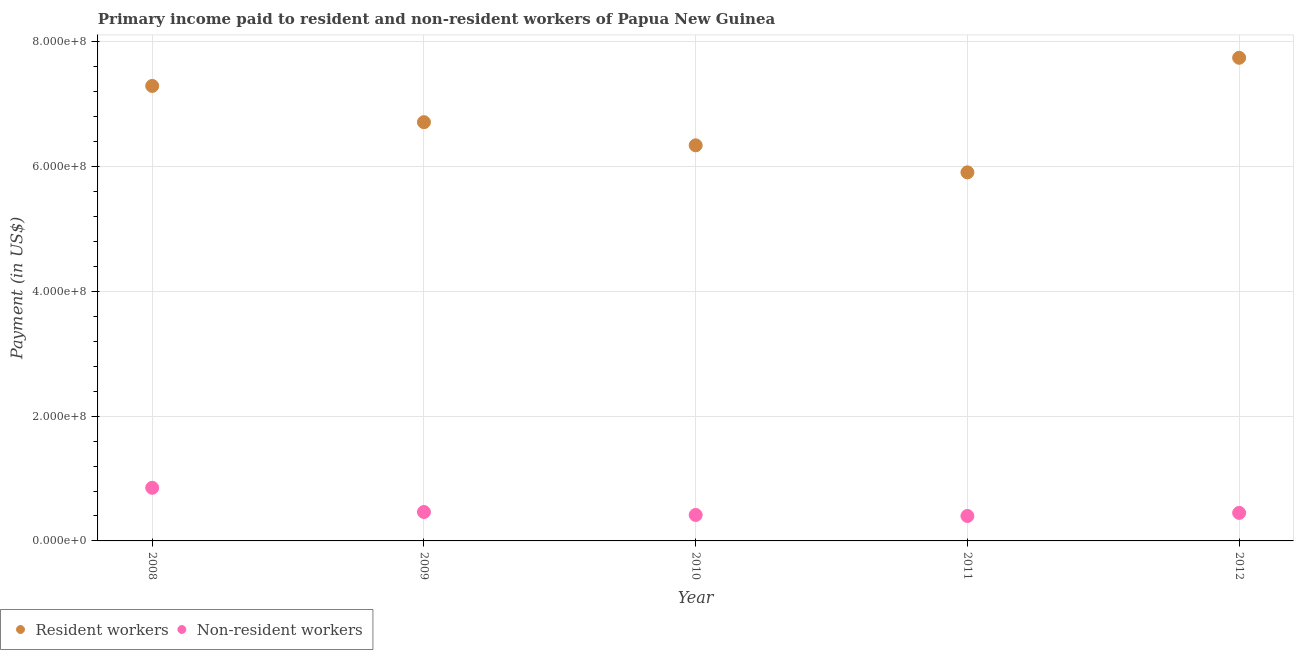How many different coloured dotlines are there?
Your answer should be very brief. 2. What is the payment made to resident workers in 2010?
Ensure brevity in your answer.  6.34e+08. Across all years, what is the maximum payment made to resident workers?
Provide a succinct answer. 7.74e+08. Across all years, what is the minimum payment made to non-resident workers?
Offer a terse response. 4.00e+07. What is the total payment made to resident workers in the graph?
Ensure brevity in your answer.  3.40e+09. What is the difference between the payment made to non-resident workers in 2011 and that in 2012?
Offer a very short reply. -4.94e+06. What is the difference between the payment made to non-resident workers in 2011 and the payment made to resident workers in 2010?
Provide a short and direct response. -5.94e+08. What is the average payment made to resident workers per year?
Offer a very short reply. 6.80e+08. In the year 2008, what is the difference between the payment made to resident workers and payment made to non-resident workers?
Your answer should be compact. 6.44e+08. In how many years, is the payment made to non-resident workers greater than 600000000 US$?
Offer a very short reply. 0. What is the ratio of the payment made to non-resident workers in 2009 to that in 2012?
Keep it short and to the point. 1.03. Is the payment made to resident workers in 2009 less than that in 2011?
Provide a short and direct response. No. What is the difference between the highest and the second highest payment made to non-resident workers?
Your answer should be very brief. 3.88e+07. What is the difference between the highest and the lowest payment made to resident workers?
Provide a short and direct response. 1.84e+08. In how many years, is the payment made to resident workers greater than the average payment made to resident workers taken over all years?
Make the answer very short. 2. Is the payment made to non-resident workers strictly greater than the payment made to resident workers over the years?
Your response must be concise. No. How many dotlines are there?
Give a very brief answer. 2. Does the graph contain any zero values?
Give a very brief answer. No. Does the graph contain grids?
Offer a very short reply. Yes. How are the legend labels stacked?
Your response must be concise. Horizontal. What is the title of the graph?
Offer a terse response. Primary income paid to resident and non-resident workers of Papua New Guinea. Does "Food" appear as one of the legend labels in the graph?
Provide a short and direct response. No. What is the label or title of the Y-axis?
Make the answer very short. Payment (in US$). What is the Payment (in US$) of Resident workers in 2008?
Give a very brief answer. 7.29e+08. What is the Payment (in US$) in Non-resident workers in 2008?
Your answer should be very brief. 8.51e+07. What is the Payment (in US$) in Resident workers in 2009?
Offer a terse response. 6.71e+08. What is the Payment (in US$) of Non-resident workers in 2009?
Offer a terse response. 4.63e+07. What is the Payment (in US$) of Resident workers in 2010?
Your answer should be very brief. 6.34e+08. What is the Payment (in US$) in Non-resident workers in 2010?
Keep it short and to the point. 4.16e+07. What is the Payment (in US$) of Resident workers in 2011?
Ensure brevity in your answer.  5.91e+08. What is the Payment (in US$) in Non-resident workers in 2011?
Your response must be concise. 4.00e+07. What is the Payment (in US$) in Resident workers in 2012?
Your answer should be very brief. 7.74e+08. What is the Payment (in US$) in Non-resident workers in 2012?
Your response must be concise. 4.49e+07. Across all years, what is the maximum Payment (in US$) in Resident workers?
Provide a short and direct response. 7.74e+08. Across all years, what is the maximum Payment (in US$) in Non-resident workers?
Make the answer very short. 8.51e+07. Across all years, what is the minimum Payment (in US$) in Resident workers?
Make the answer very short. 5.91e+08. Across all years, what is the minimum Payment (in US$) in Non-resident workers?
Make the answer very short. 4.00e+07. What is the total Payment (in US$) of Resident workers in the graph?
Provide a succinct answer. 3.40e+09. What is the total Payment (in US$) of Non-resident workers in the graph?
Keep it short and to the point. 2.58e+08. What is the difference between the Payment (in US$) in Resident workers in 2008 and that in 2009?
Keep it short and to the point. 5.81e+07. What is the difference between the Payment (in US$) of Non-resident workers in 2008 and that in 2009?
Your answer should be compact. 3.88e+07. What is the difference between the Payment (in US$) in Resident workers in 2008 and that in 2010?
Offer a terse response. 9.52e+07. What is the difference between the Payment (in US$) in Non-resident workers in 2008 and that in 2010?
Ensure brevity in your answer.  4.36e+07. What is the difference between the Payment (in US$) in Resident workers in 2008 and that in 2011?
Your response must be concise. 1.39e+08. What is the difference between the Payment (in US$) in Non-resident workers in 2008 and that in 2011?
Give a very brief answer. 4.52e+07. What is the difference between the Payment (in US$) of Resident workers in 2008 and that in 2012?
Offer a very short reply. -4.51e+07. What is the difference between the Payment (in US$) in Non-resident workers in 2008 and that in 2012?
Your response must be concise. 4.02e+07. What is the difference between the Payment (in US$) of Resident workers in 2009 and that in 2010?
Your response must be concise. 3.71e+07. What is the difference between the Payment (in US$) of Non-resident workers in 2009 and that in 2010?
Your answer should be compact. 4.76e+06. What is the difference between the Payment (in US$) in Resident workers in 2009 and that in 2011?
Make the answer very short. 8.04e+07. What is the difference between the Payment (in US$) in Non-resident workers in 2009 and that in 2011?
Make the answer very short. 6.37e+06. What is the difference between the Payment (in US$) in Resident workers in 2009 and that in 2012?
Make the answer very short. -1.03e+08. What is the difference between the Payment (in US$) in Non-resident workers in 2009 and that in 2012?
Provide a short and direct response. 1.43e+06. What is the difference between the Payment (in US$) of Resident workers in 2010 and that in 2011?
Give a very brief answer. 4.33e+07. What is the difference between the Payment (in US$) of Non-resident workers in 2010 and that in 2011?
Offer a very short reply. 1.61e+06. What is the difference between the Payment (in US$) of Resident workers in 2010 and that in 2012?
Give a very brief answer. -1.40e+08. What is the difference between the Payment (in US$) in Non-resident workers in 2010 and that in 2012?
Give a very brief answer. -3.33e+06. What is the difference between the Payment (in US$) in Resident workers in 2011 and that in 2012?
Offer a very short reply. -1.84e+08. What is the difference between the Payment (in US$) in Non-resident workers in 2011 and that in 2012?
Your response must be concise. -4.94e+06. What is the difference between the Payment (in US$) of Resident workers in 2008 and the Payment (in US$) of Non-resident workers in 2009?
Give a very brief answer. 6.83e+08. What is the difference between the Payment (in US$) of Resident workers in 2008 and the Payment (in US$) of Non-resident workers in 2010?
Offer a terse response. 6.88e+08. What is the difference between the Payment (in US$) of Resident workers in 2008 and the Payment (in US$) of Non-resident workers in 2011?
Offer a very short reply. 6.89e+08. What is the difference between the Payment (in US$) in Resident workers in 2008 and the Payment (in US$) in Non-resident workers in 2012?
Ensure brevity in your answer.  6.84e+08. What is the difference between the Payment (in US$) in Resident workers in 2009 and the Payment (in US$) in Non-resident workers in 2010?
Offer a very short reply. 6.30e+08. What is the difference between the Payment (in US$) of Resident workers in 2009 and the Payment (in US$) of Non-resident workers in 2011?
Your answer should be very brief. 6.31e+08. What is the difference between the Payment (in US$) in Resident workers in 2009 and the Payment (in US$) in Non-resident workers in 2012?
Your answer should be compact. 6.26e+08. What is the difference between the Payment (in US$) in Resident workers in 2010 and the Payment (in US$) in Non-resident workers in 2011?
Your answer should be very brief. 5.94e+08. What is the difference between the Payment (in US$) in Resident workers in 2010 and the Payment (in US$) in Non-resident workers in 2012?
Provide a short and direct response. 5.89e+08. What is the difference between the Payment (in US$) in Resident workers in 2011 and the Payment (in US$) in Non-resident workers in 2012?
Ensure brevity in your answer.  5.46e+08. What is the average Payment (in US$) in Resident workers per year?
Offer a terse response. 6.80e+08. What is the average Payment (in US$) of Non-resident workers per year?
Provide a succinct answer. 5.16e+07. In the year 2008, what is the difference between the Payment (in US$) of Resident workers and Payment (in US$) of Non-resident workers?
Your answer should be compact. 6.44e+08. In the year 2009, what is the difference between the Payment (in US$) of Resident workers and Payment (in US$) of Non-resident workers?
Keep it short and to the point. 6.25e+08. In the year 2010, what is the difference between the Payment (in US$) of Resident workers and Payment (in US$) of Non-resident workers?
Give a very brief answer. 5.92e+08. In the year 2011, what is the difference between the Payment (in US$) of Resident workers and Payment (in US$) of Non-resident workers?
Provide a short and direct response. 5.51e+08. In the year 2012, what is the difference between the Payment (in US$) of Resident workers and Payment (in US$) of Non-resident workers?
Keep it short and to the point. 7.29e+08. What is the ratio of the Payment (in US$) in Resident workers in 2008 to that in 2009?
Ensure brevity in your answer.  1.09. What is the ratio of the Payment (in US$) of Non-resident workers in 2008 to that in 2009?
Provide a succinct answer. 1.84. What is the ratio of the Payment (in US$) of Resident workers in 2008 to that in 2010?
Ensure brevity in your answer.  1.15. What is the ratio of the Payment (in US$) in Non-resident workers in 2008 to that in 2010?
Provide a succinct answer. 2.05. What is the ratio of the Payment (in US$) in Resident workers in 2008 to that in 2011?
Your answer should be compact. 1.23. What is the ratio of the Payment (in US$) of Non-resident workers in 2008 to that in 2011?
Your answer should be compact. 2.13. What is the ratio of the Payment (in US$) of Resident workers in 2008 to that in 2012?
Offer a terse response. 0.94. What is the ratio of the Payment (in US$) in Non-resident workers in 2008 to that in 2012?
Your answer should be compact. 1.9. What is the ratio of the Payment (in US$) of Resident workers in 2009 to that in 2010?
Offer a terse response. 1.06. What is the ratio of the Payment (in US$) of Non-resident workers in 2009 to that in 2010?
Provide a succinct answer. 1.11. What is the ratio of the Payment (in US$) of Resident workers in 2009 to that in 2011?
Ensure brevity in your answer.  1.14. What is the ratio of the Payment (in US$) of Non-resident workers in 2009 to that in 2011?
Your answer should be very brief. 1.16. What is the ratio of the Payment (in US$) of Resident workers in 2009 to that in 2012?
Make the answer very short. 0.87. What is the ratio of the Payment (in US$) of Non-resident workers in 2009 to that in 2012?
Your answer should be very brief. 1.03. What is the ratio of the Payment (in US$) in Resident workers in 2010 to that in 2011?
Make the answer very short. 1.07. What is the ratio of the Payment (in US$) of Non-resident workers in 2010 to that in 2011?
Keep it short and to the point. 1.04. What is the ratio of the Payment (in US$) of Resident workers in 2010 to that in 2012?
Give a very brief answer. 0.82. What is the ratio of the Payment (in US$) of Non-resident workers in 2010 to that in 2012?
Keep it short and to the point. 0.93. What is the ratio of the Payment (in US$) in Resident workers in 2011 to that in 2012?
Offer a terse response. 0.76. What is the ratio of the Payment (in US$) in Non-resident workers in 2011 to that in 2012?
Offer a very short reply. 0.89. What is the difference between the highest and the second highest Payment (in US$) in Resident workers?
Offer a terse response. 4.51e+07. What is the difference between the highest and the second highest Payment (in US$) in Non-resident workers?
Provide a short and direct response. 3.88e+07. What is the difference between the highest and the lowest Payment (in US$) in Resident workers?
Give a very brief answer. 1.84e+08. What is the difference between the highest and the lowest Payment (in US$) of Non-resident workers?
Make the answer very short. 4.52e+07. 